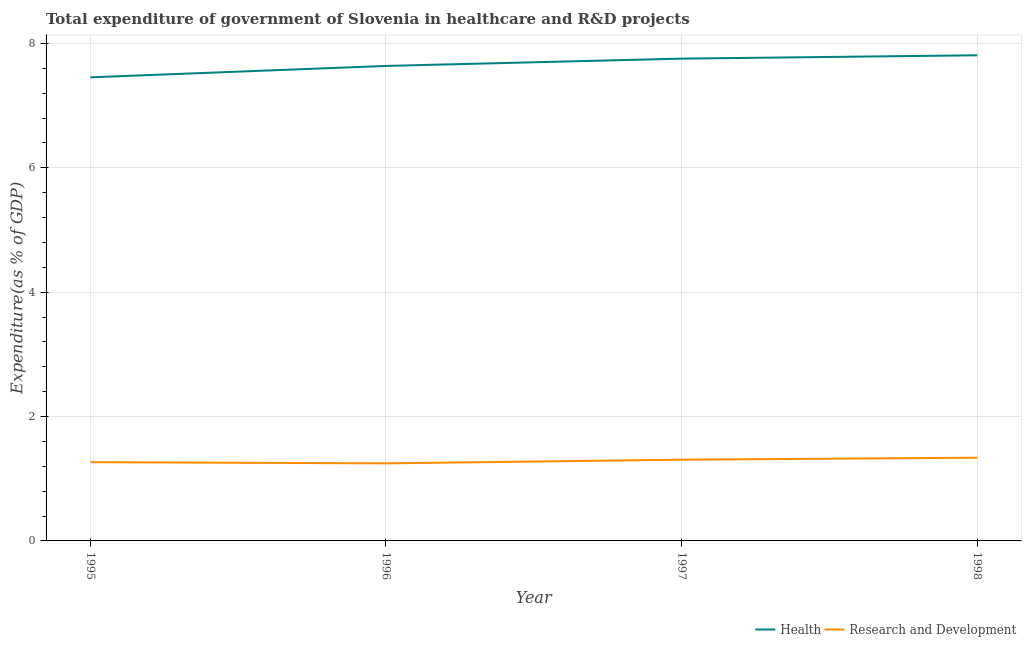Is the number of lines equal to the number of legend labels?
Provide a succinct answer. Yes. What is the expenditure in healthcare in 1998?
Offer a terse response. 7.81. Across all years, what is the maximum expenditure in healthcare?
Provide a short and direct response. 7.81. Across all years, what is the minimum expenditure in r&d?
Your answer should be compact. 1.25. What is the total expenditure in r&d in the graph?
Your response must be concise. 5.16. What is the difference between the expenditure in r&d in 1995 and that in 1998?
Your response must be concise. -0.07. What is the difference between the expenditure in r&d in 1996 and the expenditure in healthcare in 1997?
Make the answer very short. -6.51. What is the average expenditure in healthcare per year?
Offer a very short reply. 7.67. In the year 1996, what is the difference between the expenditure in r&d and expenditure in healthcare?
Your response must be concise. -6.39. In how many years, is the expenditure in r&d greater than 6.4 %?
Your response must be concise. 0. What is the ratio of the expenditure in healthcare in 1996 to that in 1998?
Your answer should be compact. 0.98. What is the difference between the highest and the second highest expenditure in healthcare?
Your answer should be compact. 0.05. What is the difference between the highest and the lowest expenditure in r&d?
Offer a terse response. 0.09. In how many years, is the expenditure in r&d greater than the average expenditure in r&d taken over all years?
Ensure brevity in your answer.  2. Is the expenditure in r&d strictly greater than the expenditure in healthcare over the years?
Ensure brevity in your answer.  No. Is the expenditure in r&d strictly less than the expenditure in healthcare over the years?
Your answer should be compact. Yes. How many lines are there?
Give a very brief answer. 2. How many years are there in the graph?
Make the answer very short. 4. What is the difference between two consecutive major ticks on the Y-axis?
Ensure brevity in your answer.  2. Where does the legend appear in the graph?
Your answer should be very brief. Bottom right. What is the title of the graph?
Ensure brevity in your answer.  Total expenditure of government of Slovenia in healthcare and R&D projects. What is the label or title of the Y-axis?
Provide a short and direct response. Expenditure(as % of GDP). What is the Expenditure(as % of GDP) in Health in 1995?
Your answer should be compact. 7.46. What is the Expenditure(as % of GDP) of Research and Development in 1995?
Provide a succinct answer. 1.27. What is the Expenditure(as % of GDP) of Health in 1996?
Offer a very short reply. 7.64. What is the Expenditure(as % of GDP) in Research and Development in 1996?
Provide a succinct answer. 1.25. What is the Expenditure(as % of GDP) of Health in 1997?
Offer a very short reply. 7.76. What is the Expenditure(as % of GDP) in Research and Development in 1997?
Provide a succinct answer. 1.31. What is the Expenditure(as % of GDP) in Health in 1998?
Make the answer very short. 7.81. What is the Expenditure(as % of GDP) in Research and Development in 1998?
Make the answer very short. 1.34. Across all years, what is the maximum Expenditure(as % of GDP) in Health?
Give a very brief answer. 7.81. Across all years, what is the maximum Expenditure(as % of GDP) in Research and Development?
Make the answer very short. 1.34. Across all years, what is the minimum Expenditure(as % of GDP) in Health?
Your answer should be compact. 7.46. Across all years, what is the minimum Expenditure(as % of GDP) in Research and Development?
Give a very brief answer. 1.25. What is the total Expenditure(as % of GDP) of Health in the graph?
Provide a succinct answer. 30.66. What is the total Expenditure(as % of GDP) of Research and Development in the graph?
Make the answer very short. 5.16. What is the difference between the Expenditure(as % of GDP) of Health in 1995 and that in 1996?
Keep it short and to the point. -0.18. What is the difference between the Expenditure(as % of GDP) in Research and Development in 1995 and that in 1996?
Provide a short and direct response. 0.02. What is the difference between the Expenditure(as % of GDP) of Health in 1995 and that in 1997?
Ensure brevity in your answer.  -0.3. What is the difference between the Expenditure(as % of GDP) of Research and Development in 1995 and that in 1997?
Make the answer very short. -0.04. What is the difference between the Expenditure(as % of GDP) in Health in 1995 and that in 1998?
Keep it short and to the point. -0.35. What is the difference between the Expenditure(as % of GDP) in Research and Development in 1995 and that in 1998?
Ensure brevity in your answer.  -0.07. What is the difference between the Expenditure(as % of GDP) in Health in 1996 and that in 1997?
Your answer should be very brief. -0.12. What is the difference between the Expenditure(as % of GDP) in Research and Development in 1996 and that in 1997?
Offer a very short reply. -0.06. What is the difference between the Expenditure(as % of GDP) in Health in 1996 and that in 1998?
Provide a succinct answer. -0.17. What is the difference between the Expenditure(as % of GDP) in Research and Development in 1996 and that in 1998?
Offer a terse response. -0.09. What is the difference between the Expenditure(as % of GDP) in Health in 1997 and that in 1998?
Keep it short and to the point. -0.05. What is the difference between the Expenditure(as % of GDP) in Research and Development in 1997 and that in 1998?
Ensure brevity in your answer.  -0.03. What is the difference between the Expenditure(as % of GDP) in Health in 1995 and the Expenditure(as % of GDP) in Research and Development in 1996?
Offer a very short reply. 6.21. What is the difference between the Expenditure(as % of GDP) of Health in 1995 and the Expenditure(as % of GDP) of Research and Development in 1997?
Provide a succinct answer. 6.15. What is the difference between the Expenditure(as % of GDP) in Health in 1995 and the Expenditure(as % of GDP) in Research and Development in 1998?
Give a very brief answer. 6.12. What is the difference between the Expenditure(as % of GDP) in Health in 1996 and the Expenditure(as % of GDP) in Research and Development in 1997?
Your answer should be compact. 6.33. What is the difference between the Expenditure(as % of GDP) in Health in 1996 and the Expenditure(as % of GDP) in Research and Development in 1998?
Your answer should be compact. 6.3. What is the difference between the Expenditure(as % of GDP) of Health in 1997 and the Expenditure(as % of GDP) of Research and Development in 1998?
Give a very brief answer. 6.42. What is the average Expenditure(as % of GDP) in Health per year?
Your answer should be compact. 7.67. What is the average Expenditure(as % of GDP) of Research and Development per year?
Your answer should be compact. 1.29. In the year 1995, what is the difference between the Expenditure(as % of GDP) in Health and Expenditure(as % of GDP) in Research and Development?
Your response must be concise. 6.19. In the year 1996, what is the difference between the Expenditure(as % of GDP) in Health and Expenditure(as % of GDP) in Research and Development?
Your answer should be very brief. 6.39. In the year 1997, what is the difference between the Expenditure(as % of GDP) of Health and Expenditure(as % of GDP) of Research and Development?
Your answer should be very brief. 6.45. In the year 1998, what is the difference between the Expenditure(as % of GDP) of Health and Expenditure(as % of GDP) of Research and Development?
Provide a succinct answer. 6.47. What is the ratio of the Expenditure(as % of GDP) of Research and Development in 1995 to that in 1996?
Make the answer very short. 1.02. What is the ratio of the Expenditure(as % of GDP) in Health in 1995 to that in 1997?
Provide a short and direct response. 0.96. What is the ratio of the Expenditure(as % of GDP) of Research and Development in 1995 to that in 1997?
Make the answer very short. 0.97. What is the ratio of the Expenditure(as % of GDP) in Health in 1995 to that in 1998?
Your answer should be very brief. 0.95. What is the ratio of the Expenditure(as % of GDP) in Research and Development in 1995 to that in 1998?
Offer a terse response. 0.95. What is the ratio of the Expenditure(as % of GDP) of Research and Development in 1996 to that in 1997?
Your answer should be very brief. 0.95. What is the ratio of the Expenditure(as % of GDP) in Health in 1996 to that in 1998?
Provide a succinct answer. 0.98. What is the ratio of the Expenditure(as % of GDP) of Research and Development in 1996 to that in 1998?
Keep it short and to the point. 0.93. What is the ratio of the Expenditure(as % of GDP) of Research and Development in 1997 to that in 1998?
Provide a succinct answer. 0.98. What is the difference between the highest and the second highest Expenditure(as % of GDP) of Health?
Offer a very short reply. 0.05. What is the difference between the highest and the second highest Expenditure(as % of GDP) of Research and Development?
Make the answer very short. 0.03. What is the difference between the highest and the lowest Expenditure(as % of GDP) of Health?
Your response must be concise. 0.35. What is the difference between the highest and the lowest Expenditure(as % of GDP) in Research and Development?
Offer a terse response. 0.09. 